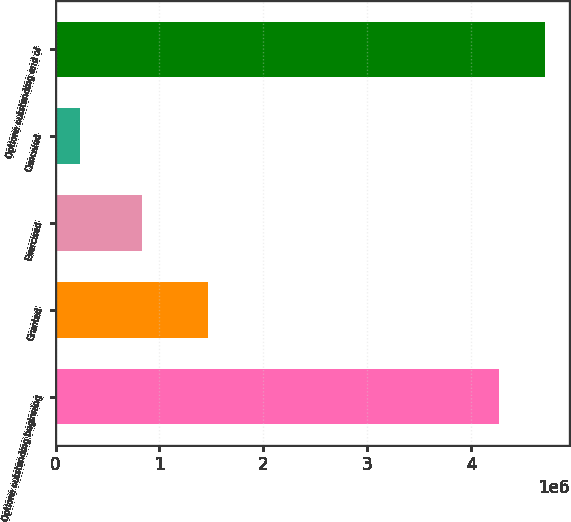Convert chart to OTSL. <chart><loc_0><loc_0><loc_500><loc_500><bar_chart><fcel>Options outstanding beginning<fcel>Granted<fcel>Exercised<fcel>Canceled<fcel>Options outstanding end of<nl><fcel>4.26882e+06<fcel>1.467e+06<fcel>832200<fcel>238200<fcel>4.71154e+06<nl></chart> 